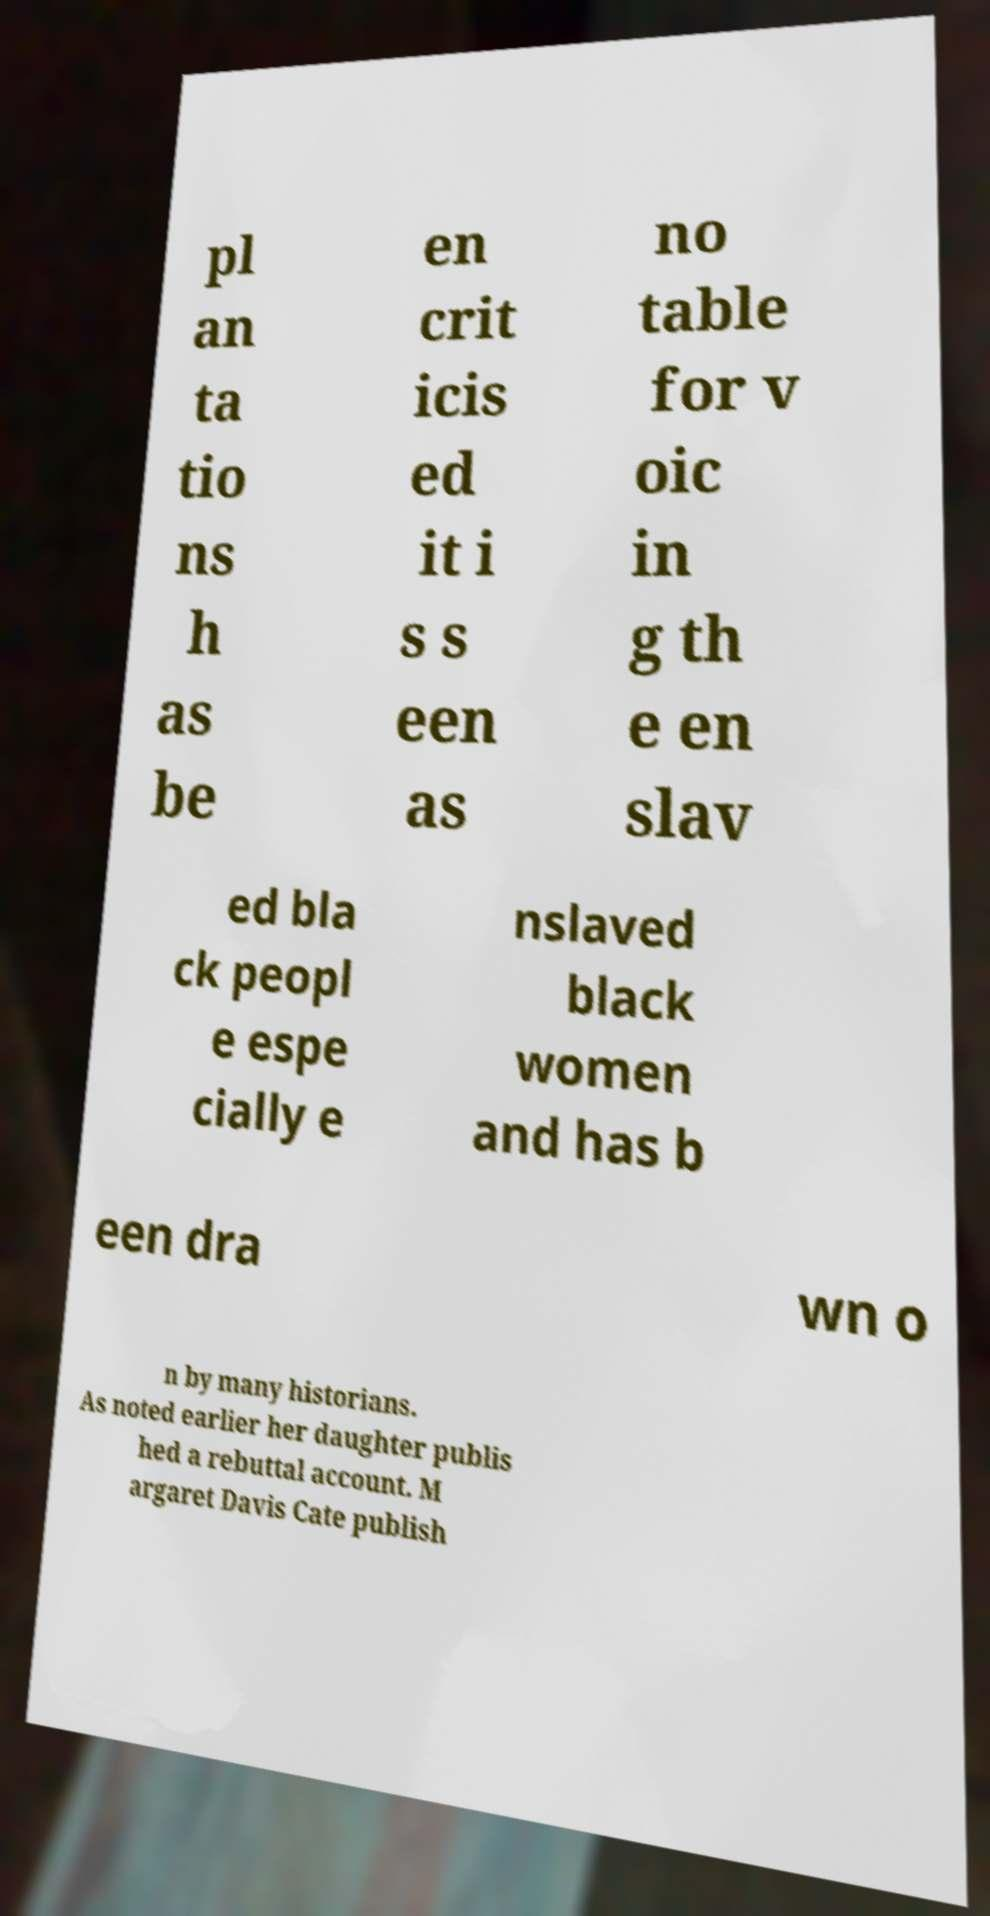Please read and relay the text visible in this image. What does it say? pl an ta tio ns h as be en crit icis ed it i s s een as no table for v oic in g th e en slav ed bla ck peopl e espe cially e nslaved black women and has b een dra wn o n by many historians. As noted earlier her daughter publis hed a rebuttal account. M argaret Davis Cate publish 